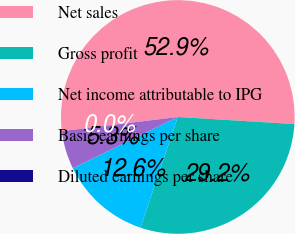Convert chart. <chart><loc_0><loc_0><loc_500><loc_500><pie_chart><fcel>Net sales<fcel>Gross profit<fcel>Net income attributable to IPG<fcel>Basic earnings per share<fcel>Diluted earnings per share<nl><fcel>52.91%<fcel>29.21%<fcel>12.59%<fcel>5.29%<fcel>0.0%<nl></chart> 